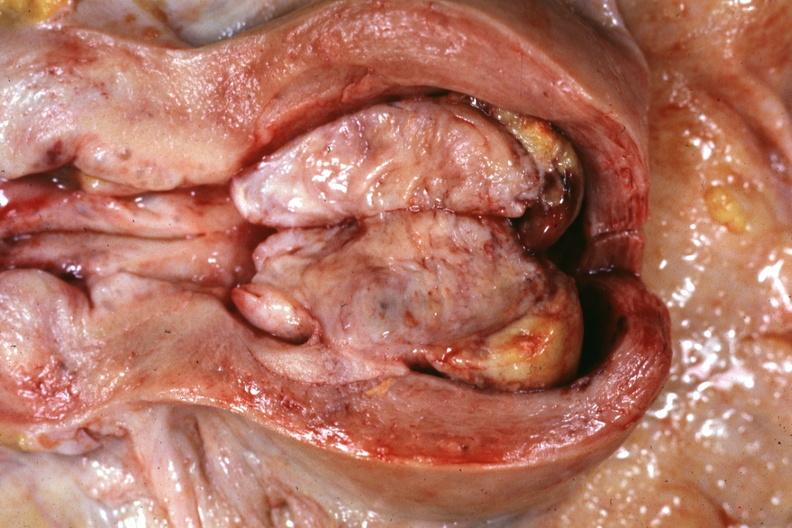what is present?
Answer the question using a single word or phrase. Female reproductive 